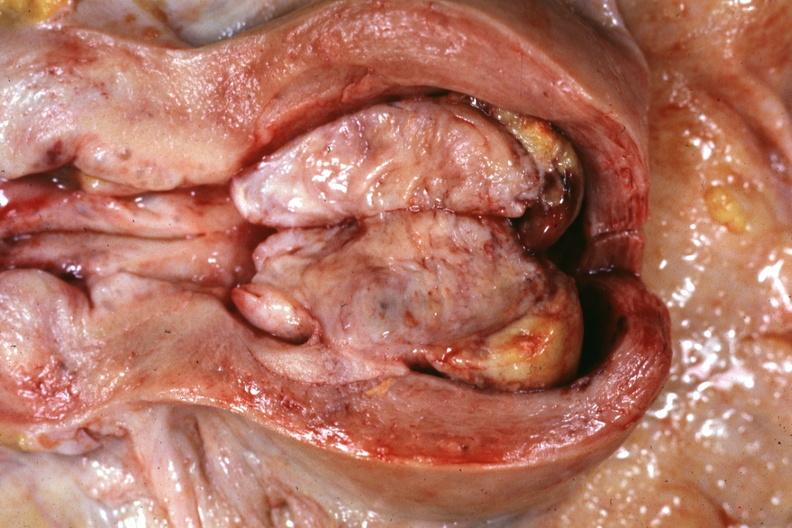what is present?
Answer the question using a single word or phrase. Female reproductive 